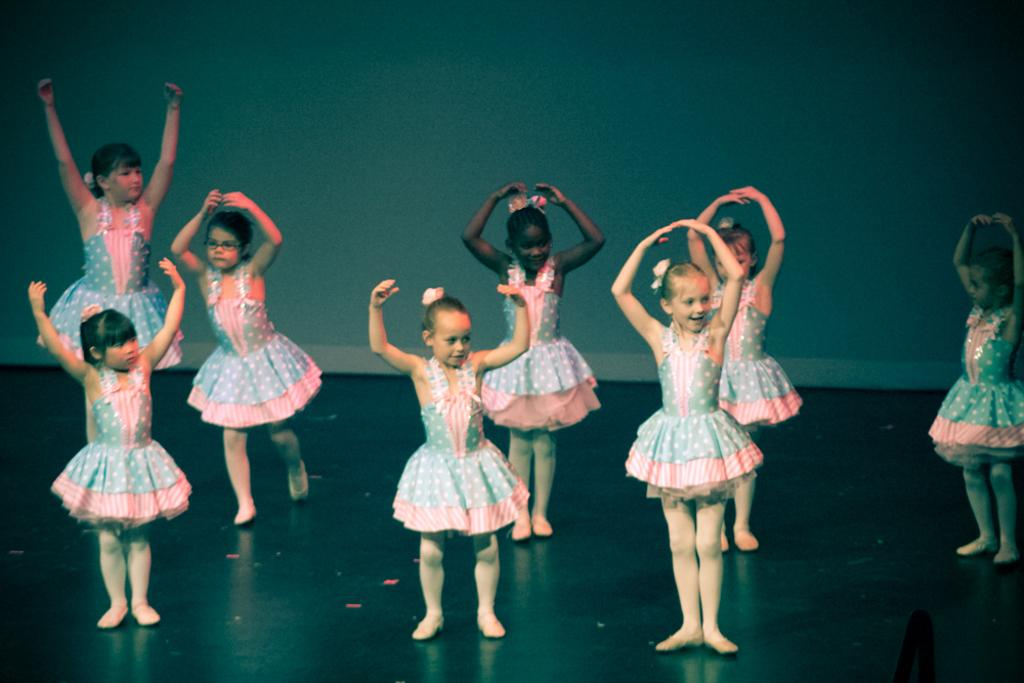What is happening in the image? There are girls in the image, and they are dancing. What are the girls doing with their hands? The girls are raising their hands. What are the girls wearing? The girls are wearing frocks. What type of drum can be heard in the background of the image? There is no drum or background music present in the image; it only shows the girls dancing and raising their hands. 